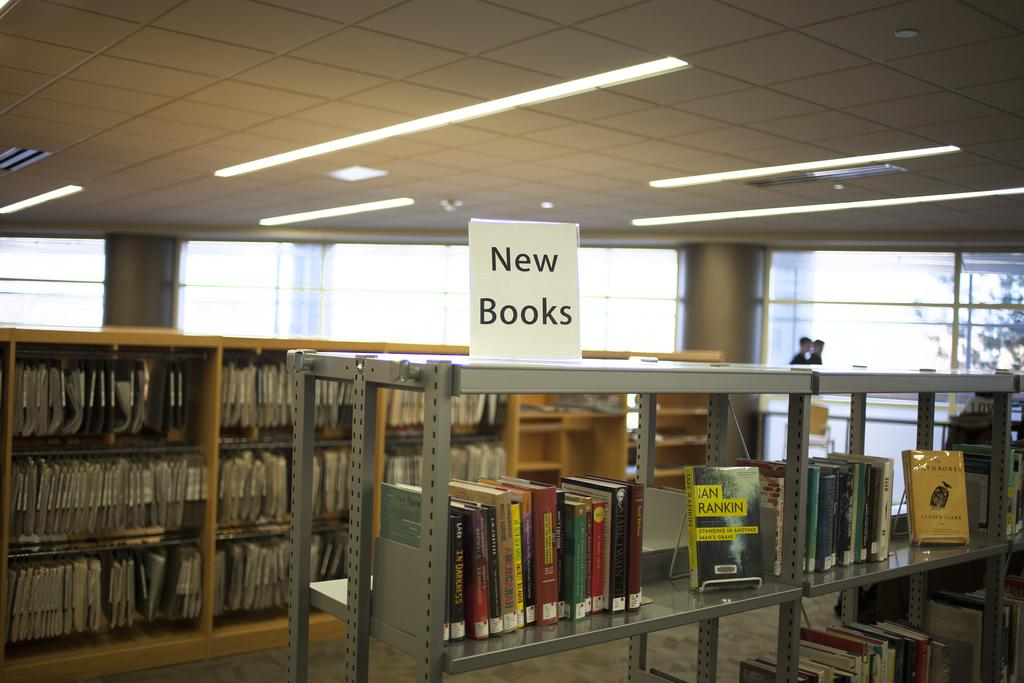<image>
Give a short and clear explanation of the subsequent image. A shelf full of books with the sign reading new books on the top of the shelf. 